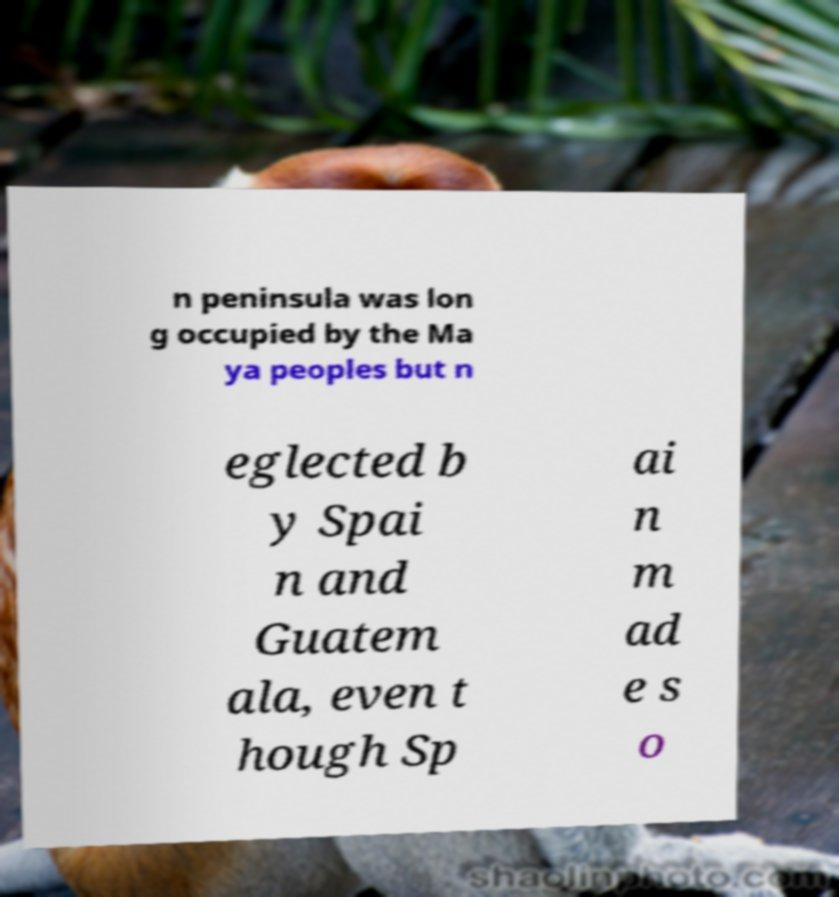Can you read and provide the text displayed in the image?This photo seems to have some interesting text. Can you extract and type it out for me? n peninsula was lon g occupied by the Ma ya peoples but n eglected b y Spai n and Guatem ala, even t hough Sp ai n m ad e s o 